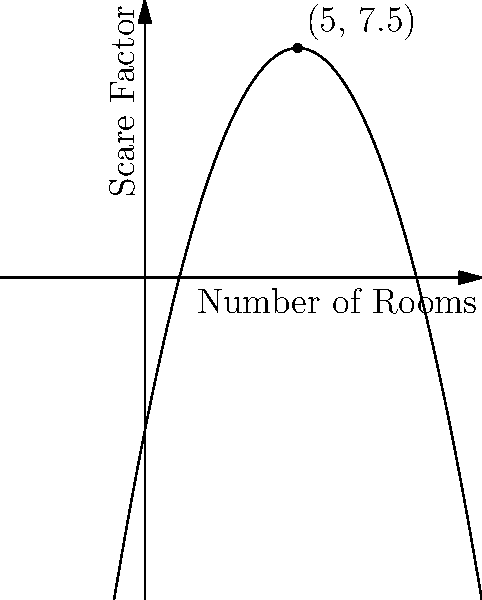As a horror film director, you're designing a haunted house attraction. The scare factor (S) of the haunted house can be modeled by the quadratic function $S(x) = -0.5x^2 + 5x - 5$, where x is the number of rooms. What is the optimal number of rooms to maximize the scare factor, and what is the maximum scare factor achieved? To find the optimal number of rooms and maximum scare factor:

1. The function $S(x) = -0.5x^2 + 5x - 5$ is a quadratic function with a negative leading coefficient, so it opens downward and has a maximum point.

2. To find the vertex (maximum point), we can use the formula $x = -\frac{b}{2a}$, where $a$ and $b$ are the coefficients of $x^2$ and $x$ respectively.

3. $a = -0.5$ and $b = 5$
   $x = -\frac{5}{2(-0.5)} = \frac{5}{1} = 5$

4. The optimal number of rooms is 5.

5. To find the maximum scare factor, plug x = 5 into the original function:
   $S(5) = -0.5(5)^2 + 5(5) - 5$
   $= -0.5(25) + 25 - 5$
   $= -12.5 + 25 - 5$
   $= 7.5$

6. The maximum scare factor achieved is 7.5.

Therefore, the optimal number of rooms is 5, and the maximum scare factor achieved is 7.5.
Answer: 5 rooms; 7.5 scare factor 